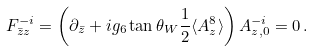<formula> <loc_0><loc_0><loc_500><loc_500>F _ { \bar { z } z } ^ { - i } = \left ( \partial _ { \bar { z } } + i g _ { 6 } \tan \theta _ { W } \frac { 1 } { 2 } \langle A _ { z } ^ { 8 } \rangle \right ) A _ { z , 0 } ^ { - i } = 0 \, .</formula> 